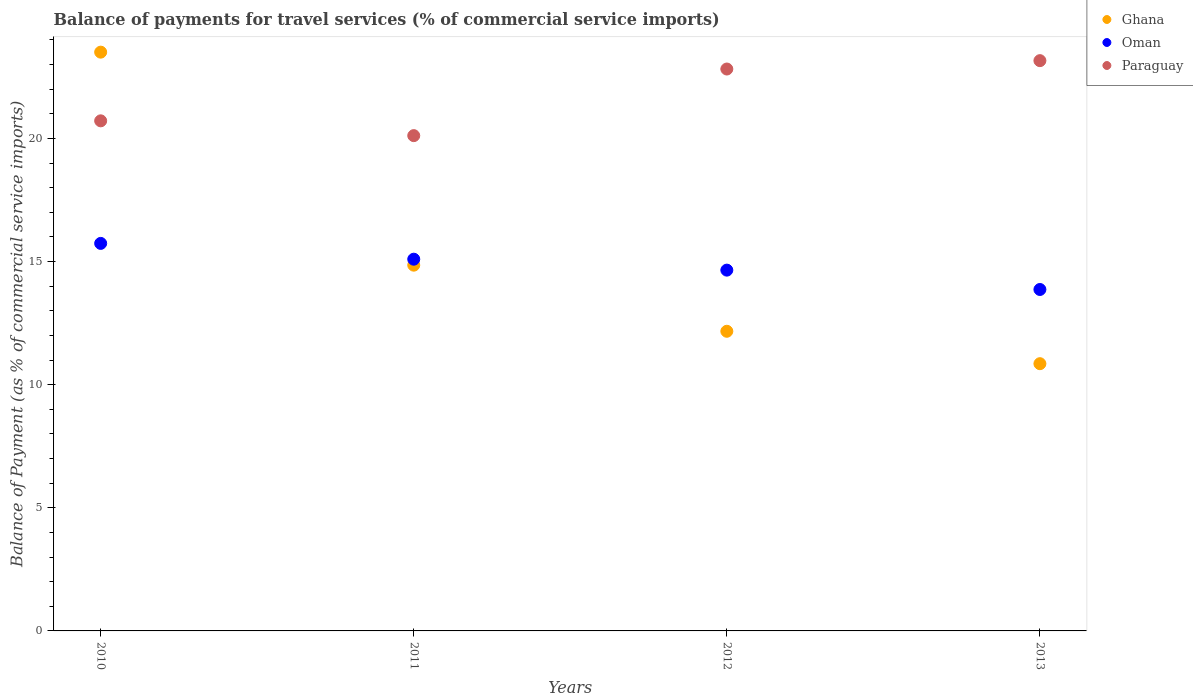What is the balance of payments for travel services in Oman in 2013?
Offer a very short reply. 13.86. Across all years, what is the maximum balance of payments for travel services in Ghana?
Offer a terse response. 23.5. Across all years, what is the minimum balance of payments for travel services in Oman?
Keep it short and to the point. 13.86. What is the total balance of payments for travel services in Oman in the graph?
Offer a terse response. 59.35. What is the difference between the balance of payments for travel services in Paraguay in 2012 and that in 2013?
Provide a short and direct response. -0.34. What is the difference between the balance of payments for travel services in Paraguay in 2011 and the balance of payments for travel services in Oman in 2010?
Give a very brief answer. 4.38. What is the average balance of payments for travel services in Oman per year?
Your response must be concise. 14.84. In the year 2012, what is the difference between the balance of payments for travel services in Ghana and balance of payments for travel services in Paraguay?
Provide a succinct answer. -10.65. What is the ratio of the balance of payments for travel services in Oman in 2011 to that in 2013?
Your answer should be compact. 1.09. Is the balance of payments for travel services in Paraguay in 2011 less than that in 2013?
Keep it short and to the point. Yes. What is the difference between the highest and the second highest balance of payments for travel services in Paraguay?
Your answer should be compact. 0.34. What is the difference between the highest and the lowest balance of payments for travel services in Oman?
Your answer should be very brief. 1.87. In how many years, is the balance of payments for travel services in Paraguay greater than the average balance of payments for travel services in Paraguay taken over all years?
Make the answer very short. 2. Is the sum of the balance of payments for travel services in Paraguay in 2010 and 2011 greater than the maximum balance of payments for travel services in Oman across all years?
Give a very brief answer. Yes. Does the balance of payments for travel services in Ghana monotonically increase over the years?
Your response must be concise. No. Is the balance of payments for travel services in Ghana strictly greater than the balance of payments for travel services in Paraguay over the years?
Ensure brevity in your answer.  No. Is the balance of payments for travel services in Paraguay strictly less than the balance of payments for travel services in Oman over the years?
Give a very brief answer. No. How many dotlines are there?
Your answer should be very brief. 3. Are the values on the major ticks of Y-axis written in scientific E-notation?
Offer a terse response. No. Does the graph contain grids?
Provide a short and direct response. No. How many legend labels are there?
Ensure brevity in your answer.  3. How are the legend labels stacked?
Your answer should be very brief. Vertical. What is the title of the graph?
Your answer should be very brief. Balance of payments for travel services (% of commercial service imports). What is the label or title of the X-axis?
Your response must be concise. Years. What is the label or title of the Y-axis?
Your answer should be very brief. Balance of Payment (as % of commercial service imports). What is the Balance of Payment (as % of commercial service imports) in Ghana in 2010?
Offer a very short reply. 23.5. What is the Balance of Payment (as % of commercial service imports) in Oman in 2010?
Keep it short and to the point. 15.74. What is the Balance of Payment (as % of commercial service imports) of Paraguay in 2010?
Your answer should be very brief. 20.71. What is the Balance of Payment (as % of commercial service imports) in Ghana in 2011?
Your response must be concise. 14.85. What is the Balance of Payment (as % of commercial service imports) of Oman in 2011?
Give a very brief answer. 15.09. What is the Balance of Payment (as % of commercial service imports) in Paraguay in 2011?
Make the answer very short. 20.11. What is the Balance of Payment (as % of commercial service imports) in Ghana in 2012?
Your answer should be very brief. 12.17. What is the Balance of Payment (as % of commercial service imports) of Oman in 2012?
Ensure brevity in your answer.  14.65. What is the Balance of Payment (as % of commercial service imports) of Paraguay in 2012?
Your response must be concise. 22.82. What is the Balance of Payment (as % of commercial service imports) of Ghana in 2013?
Your answer should be very brief. 10.85. What is the Balance of Payment (as % of commercial service imports) in Oman in 2013?
Provide a short and direct response. 13.86. What is the Balance of Payment (as % of commercial service imports) in Paraguay in 2013?
Provide a succinct answer. 23.16. Across all years, what is the maximum Balance of Payment (as % of commercial service imports) of Ghana?
Your answer should be very brief. 23.5. Across all years, what is the maximum Balance of Payment (as % of commercial service imports) in Oman?
Keep it short and to the point. 15.74. Across all years, what is the maximum Balance of Payment (as % of commercial service imports) in Paraguay?
Your answer should be compact. 23.16. Across all years, what is the minimum Balance of Payment (as % of commercial service imports) of Ghana?
Keep it short and to the point. 10.85. Across all years, what is the minimum Balance of Payment (as % of commercial service imports) of Oman?
Ensure brevity in your answer.  13.86. Across all years, what is the minimum Balance of Payment (as % of commercial service imports) of Paraguay?
Your answer should be compact. 20.11. What is the total Balance of Payment (as % of commercial service imports) in Ghana in the graph?
Offer a very short reply. 61.37. What is the total Balance of Payment (as % of commercial service imports) of Oman in the graph?
Your answer should be compact. 59.35. What is the total Balance of Payment (as % of commercial service imports) in Paraguay in the graph?
Provide a short and direct response. 86.8. What is the difference between the Balance of Payment (as % of commercial service imports) in Ghana in 2010 and that in 2011?
Offer a terse response. 8.65. What is the difference between the Balance of Payment (as % of commercial service imports) of Oman in 2010 and that in 2011?
Your answer should be compact. 0.64. What is the difference between the Balance of Payment (as % of commercial service imports) of Paraguay in 2010 and that in 2011?
Your answer should be compact. 0.6. What is the difference between the Balance of Payment (as % of commercial service imports) of Ghana in 2010 and that in 2012?
Provide a short and direct response. 11.33. What is the difference between the Balance of Payment (as % of commercial service imports) in Oman in 2010 and that in 2012?
Offer a very short reply. 1.09. What is the difference between the Balance of Payment (as % of commercial service imports) of Paraguay in 2010 and that in 2012?
Give a very brief answer. -2.1. What is the difference between the Balance of Payment (as % of commercial service imports) of Ghana in 2010 and that in 2013?
Offer a very short reply. 12.65. What is the difference between the Balance of Payment (as % of commercial service imports) in Oman in 2010 and that in 2013?
Your answer should be very brief. 1.87. What is the difference between the Balance of Payment (as % of commercial service imports) of Paraguay in 2010 and that in 2013?
Ensure brevity in your answer.  -2.44. What is the difference between the Balance of Payment (as % of commercial service imports) in Ghana in 2011 and that in 2012?
Offer a very short reply. 2.68. What is the difference between the Balance of Payment (as % of commercial service imports) in Oman in 2011 and that in 2012?
Provide a succinct answer. 0.44. What is the difference between the Balance of Payment (as % of commercial service imports) of Paraguay in 2011 and that in 2012?
Your answer should be compact. -2.71. What is the difference between the Balance of Payment (as % of commercial service imports) in Ghana in 2011 and that in 2013?
Ensure brevity in your answer.  4. What is the difference between the Balance of Payment (as % of commercial service imports) in Oman in 2011 and that in 2013?
Offer a very short reply. 1.23. What is the difference between the Balance of Payment (as % of commercial service imports) of Paraguay in 2011 and that in 2013?
Give a very brief answer. -3.04. What is the difference between the Balance of Payment (as % of commercial service imports) in Ghana in 2012 and that in 2013?
Offer a terse response. 1.32. What is the difference between the Balance of Payment (as % of commercial service imports) of Oman in 2012 and that in 2013?
Make the answer very short. 0.79. What is the difference between the Balance of Payment (as % of commercial service imports) in Paraguay in 2012 and that in 2013?
Keep it short and to the point. -0.34. What is the difference between the Balance of Payment (as % of commercial service imports) of Ghana in 2010 and the Balance of Payment (as % of commercial service imports) of Oman in 2011?
Make the answer very short. 8.41. What is the difference between the Balance of Payment (as % of commercial service imports) in Ghana in 2010 and the Balance of Payment (as % of commercial service imports) in Paraguay in 2011?
Make the answer very short. 3.39. What is the difference between the Balance of Payment (as % of commercial service imports) of Oman in 2010 and the Balance of Payment (as % of commercial service imports) of Paraguay in 2011?
Offer a very short reply. -4.38. What is the difference between the Balance of Payment (as % of commercial service imports) in Ghana in 2010 and the Balance of Payment (as % of commercial service imports) in Oman in 2012?
Keep it short and to the point. 8.85. What is the difference between the Balance of Payment (as % of commercial service imports) in Ghana in 2010 and the Balance of Payment (as % of commercial service imports) in Paraguay in 2012?
Offer a terse response. 0.69. What is the difference between the Balance of Payment (as % of commercial service imports) of Oman in 2010 and the Balance of Payment (as % of commercial service imports) of Paraguay in 2012?
Make the answer very short. -7.08. What is the difference between the Balance of Payment (as % of commercial service imports) of Ghana in 2010 and the Balance of Payment (as % of commercial service imports) of Oman in 2013?
Your response must be concise. 9.64. What is the difference between the Balance of Payment (as % of commercial service imports) in Ghana in 2010 and the Balance of Payment (as % of commercial service imports) in Paraguay in 2013?
Make the answer very short. 0.35. What is the difference between the Balance of Payment (as % of commercial service imports) in Oman in 2010 and the Balance of Payment (as % of commercial service imports) in Paraguay in 2013?
Provide a short and direct response. -7.42. What is the difference between the Balance of Payment (as % of commercial service imports) of Ghana in 2011 and the Balance of Payment (as % of commercial service imports) of Oman in 2012?
Your response must be concise. 0.2. What is the difference between the Balance of Payment (as % of commercial service imports) in Ghana in 2011 and the Balance of Payment (as % of commercial service imports) in Paraguay in 2012?
Give a very brief answer. -7.96. What is the difference between the Balance of Payment (as % of commercial service imports) in Oman in 2011 and the Balance of Payment (as % of commercial service imports) in Paraguay in 2012?
Offer a very short reply. -7.72. What is the difference between the Balance of Payment (as % of commercial service imports) in Ghana in 2011 and the Balance of Payment (as % of commercial service imports) in Oman in 2013?
Your response must be concise. 0.99. What is the difference between the Balance of Payment (as % of commercial service imports) in Ghana in 2011 and the Balance of Payment (as % of commercial service imports) in Paraguay in 2013?
Provide a succinct answer. -8.3. What is the difference between the Balance of Payment (as % of commercial service imports) of Oman in 2011 and the Balance of Payment (as % of commercial service imports) of Paraguay in 2013?
Offer a terse response. -8.06. What is the difference between the Balance of Payment (as % of commercial service imports) of Ghana in 2012 and the Balance of Payment (as % of commercial service imports) of Oman in 2013?
Your answer should be very brief. -1.7. What is the difference between the Balance of Payment (as % of commercial service imports) of Ghana in 2012 and the Balance of Payment (as % of commercial service imports) of Paraguay in 2013?
Keep it short and to the point. -10.99. What is the difference between the Balance of Payment (as % of commercial service imports) in Oman in 2012 and the Balance of Payment (as % of commercial service imports) in Paraguay in 2013?
Your answer should be compact. -8.51. What is the average Balance of Payment (as % of commercial service imports) in Ghana per year?
Your answer should be very brief. 15.34. What is the average Balance of Payment (as % of commercial service imports) of Oman per year?
Your answer should be very brief. 14.84. What is the average Balance of Payment (as % of commercial service imports) in Paraguay per year?
Provide a short and direct response. 21.7. In the year 2010, what is the difference between the Balance of Payment (as % of commercial service imports) in Ghana and Balance of Payment (as % of commercial service imports) in Oman?
Keep it short and to the point. 7.77. In the year 2010, what is the difference between the Balance of Payment (as % of commercial service imports) of Ghana and Balance of Payment (as % of commercial service imports) of Paraguay?
Provide a succinct answer. 2.79. In the year 2010, what is the difference between the Balance of Payment (as % of commercial service imports) in Oman and Balance of Payment (as % of commercial service imports) in Paraguay?
Your response must be concise. -4.98. In the year 2011, what is the difference between the Balance of Payment (as % of commercial service imports) of Ghana and Balance of Payment (as % of commercial service imports) of Oman?
Give a very brief answer. -0.24. In the year 2011, what is the difference between the Balance of Payment (as % of commercial service imports) in Ghana and Balance of Payment (as % of commercial service imports) in Paraguay?
Your answer should be compact. -5.26. In the year 2011, what is the difference between the Balance of Payment (as % of commercial service imports) of Oman and Balance of Payment (as % of commercial service imports) of Paraguay?
Offer a very short reply. -5.02. In the year 2012, what is the difference between the Balance of Payment (as % of commercial service imports) in Ghana and Balance of Payment (as % of commercial service imports) in Oman?
Provide a short and direct response. -2.48. In the year 2012, what is the difference between the Balance of Payment (as % of commercial service imports) in Ghana and Balance of Payment (as % of commercial service imports) in Paraguay?
Make the answer very short. -10.65. In the year 2012, what is the difference between the Balance of Payment (as % of commercial service imports) in Oman and Balance of Payment (as % of commercial service imports) in Paraguay?
Ensure brevity in your answer.  -8.17. In the year 2013, what is the difference between the Balance of Payment (as % of commercial service imports) in Ghana and Balance of Payment (as % of commercial service imports) in Oman?
Keep it short and to the point. -3.01. In the year 2013, what is the difference between the Balance of Payment (as % of commercial service imports) in Ghana and Balance of Payment (as % of commercial service imports) in Paraguay?
Give a very brief answer. -12.31. In the year 2013, what is the difference between the Balance of Payment (as % of commercial service imports) of Oman and Balance of Payment (as % of commercial service imports) of Paraguay?
Offer a very short reply. -9.29. What is the ratio of the Balance of Payment (as % of commercial service imports) of Ghana in 2010 to that in 2011?
Provide a short and direct response. 1.58. What is the ratio of the Balance of Payment (as % of commercial service imports) of Oman in 2010 to that in 2011?
Your answer should be very brief. 1.04. What is the ratio of the Balance of Payment (as % of commercial service imports) of Paraguay in 2010 to that in 2011?
Your answer should be compact. 1.03. What is the ratio of the Balance of Payment (as % of commercial service imports) of Ghana in 2010 to that in 2012?
Offer a very short reply. 1.93. What is the ratio of the Balance of Payment (as % of commercial service imports) of Oman in 2010 to that in 2012?
Your response must be concise. 1.07. What is the ratio of the Balance of Payment (as % of commercial service imports) in Paraguay in 2010 to that in 2012?
Give a very brief answer. 0.91. What is the ratio of the Balance of Payment (as % of commercial service imports) in Ghana in 2010 to that in 2013?
Make the answer very short. 2.17. What is the ratio of the Balance of Payment (as % of commercial service imports) of Oman in 2010 to that in 2013?
Your response must be concise. 1.14. What is the ratio of the Balance of Payment (as % of commercial service imports) in Paraguay in 2010 to that in 2013?
Offer a very short reply. 0.89. What is the ratio of the Balance of Payment (as % of commercial service imports) of Ghana in 2011 to that in 2012?
Your response must be concise. 1.22. What is the ratio of the Balance of Payment (as % of commercial service imports) in Oman in 2011 to that in 2012?
Ensure brevity in your answer.  1.03. What is the ratio of the Balance of Payment (as % of commercial service imports) of Paraguay in 2011 to that in 2012?
Offer a very short reply. 0.88. What is the ratio of the Balance of Payment (as % of commercial service imports) in Ghana in 2011 to that in 2013?
Your answer should be compact. 1.37. What is the ratio of the Balance of Payment (as % of commercial service imports) of Oman in 2011 to that in 2013?
Make the answer very short. 1.09. What is the ratio of the Balance of Payment (as % of commercial service imports) in Paraguay in 2011 to that in 2013?
Offer a very short reply. 0.87. What is the ratio of the Balance of Payment (as % of commercial service imports) in Ghana in 2012 to that in 2013?
Your answer should be very brief. 1.12. What is the ratio of the Balance of Payment (as % of commercial service imports) of Oman in 2012 to that in 2013?
Your answer should be compact. 1.06. What is the difference between the highest and the second highest Balance of Payment (as % of commercial service imports) of Ghana?
Your response must be concise. 8.65. What is the difference between the highest and the second highest Balance of Payment (as % of commercial service imports) of Oman?
Give a very brief answer. 0.64. What is the difference between the highest and the second highest Balance of Payment (as % of commercial service imports) of Paraguay?
Your answer should be very brief. 0.34. What is the difference between the highest and the lowest Balance of Payment (as % of commercial service imports) of Ghana?
Give a very brief answer. 12.65. What is the difference between the highest and the lowest Balance of Payment (as % of commercial service imports) of Oman?
Your answer should be compact. 1.87. What is the difference between the highest and the lowest Balance of Payment (as % of commercial service imports) of Paraguay?
Ensure brevity in your answer.  3.04. 